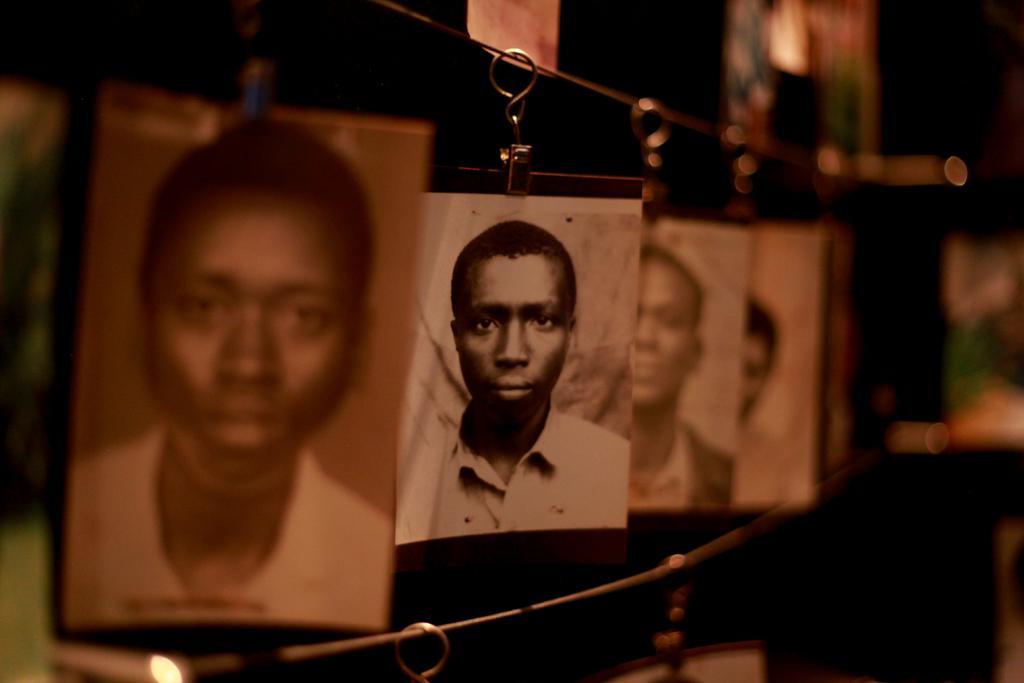Could you give a brief overview of what you see in this image? In this picture, we see the four images of men are hanged to the wires. These images are in black and white. In the background, we see some objects in white and green color. In the background, it is black in color. This picture is blurred in the background. 